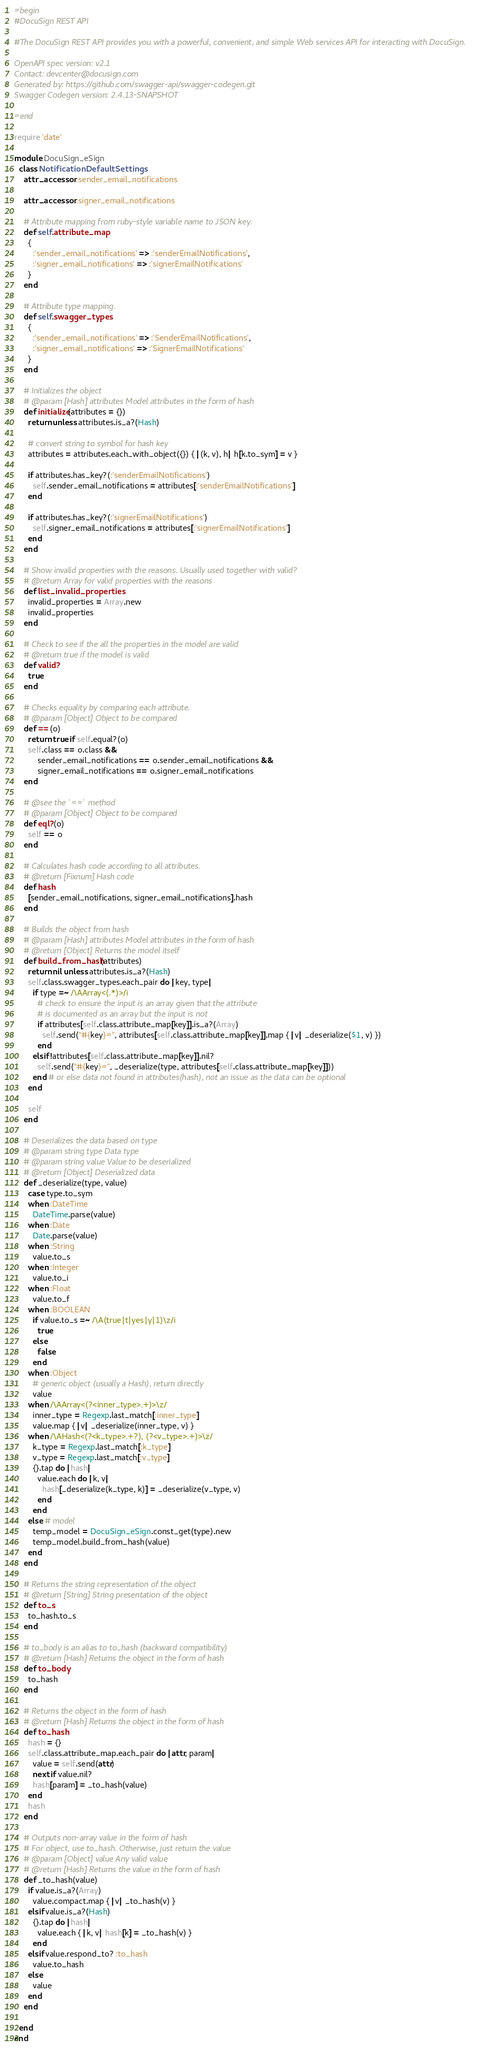<code> <loc_0><loc_0><loc_500><loc_500><_Ruby_>=begin
#DocuSign REST API

#The DocuSign REST API provides you with a powerful, convenient, and simple Web services API for interacting with DocuSign.

OpenAPI spec version: v2.1
Contact: devcenter@docusign.com
Generated by: https://github.com/swagger-api/swagger-codegen.git
Swagger Codegen version: 2.4.13-SNAPSHOT

=end

require 'date'

module DocuSign_eSign
  class NotificationDefaultSettings
    attr_accessor :sender_email_notifications

    attr_accessor :signer_email_notifications

    # Attribute mapping from ruby-style variable name to JSON key.
    def self.attribute_map
      {
        :'sender_email_notifications' => :'senderEmailNotifications',
        :'signer_email_notifications' => :'signerEmailNotifications'
      }
    end

    # Attribute type mapping.
    def self.swagger_types
      {
        :'sender_email_notifications' => :'SenderEmailNotifications',
        :'signer_email_notifications' => :'SignerEmailNotifications'
      }
    end

    # Initializes the object
    # @param [Hash] attributes Model attributes in the form of hash
    def initialize(attributes = {})
      return unless attributes.is_a?(Hash)

      # convert string to symbol for hash key
      attributes = attributes.each_with_object({}) { |(k, v), h| h[k.to_sym] = v }

      if attributes.has_key?(:'senderEmailNotifications')
        self.sender_email_notifications = attributes[:'senderEmailNotifications']
      end

      if attributes.has_key?(:'signerEmailNotifications')
        self.signer_email_notifications = attributes[:'signerEmailNotifications']
      end
    end

    # Show invalid properties with the reasons. Usually used together with valid?
    # @return Array for valid properties with the reasons
    def list_invalid_properties
      invalid_properties = Array.new
      invalid_properties
    end

    # Check to see if the all the properties in the model are valid
    # @return true if the model is valid
    def valid?
      true
    end

    # Checks equality by comparing each attribute.
    # @param [Object] Object to be compared
    def ==(o)
      return true if self.equal?(o)
      self.class == o.class &&
          sender_email_notifications == o.sender_email_notifications &&
          signer_email_notifications == o.signer_email_notifications
    end

    # @see the `==` method
    # @param [Object] Object to be compared
    def eql?(o)
      self == o
    end

    # Calculates hash code according to all attributes.
    # @return [Fixnum] Hash code
    def hash
      [sender_email_notifications, signer_email_notifications].hash
    end

    # Builds the object from hash
    # @param [Hash] attributes Model attributes in the form of hash
    # @return [Object] Returns the model itself
    def build_from_hash(attributes)
      return nil unless attributes.is_a?(Hash)
      self.class.swagger_types.each_pair do |key, type|
        if type =~ /\AArray<(.*)>/i
          # check to ensure the input is an array given that the attribute
          # is documented as an array but the input is not
          if attributes[self.class.attribute_map[key]].is_a?(Array)
            self.send("#{key}=", attributes[self.class.attribute_map[key]].map { |v| _deserialize($1, v) })
          end
        elsif !attributes[self.class.attribute_map[key]].nil?
          self.send("#{key}=", _deserialize(type, attributes[self.class.attribute_map[key]]))
        end # or else data not found in attributes(hash), not an issue as the data can be optional
      end

      self
    end

    # Deserializes the data based on type
    # @param string type Data type
    # @param string value Value to be deserialized
    # @return [Object] Deserialized data
    def _deserialize(type, value)
      case type.to_sym
      when :DateTime
        DateTime.parse(value)
      when :Date
        Date.parse(value)
      when :String
        value.to_s
      when :Integer
        value.to_i
      when :Float
        value.to_f
      when :BOOLEAN
        if value.to_s =~ /\A(true|t|yes|y|1)\z/i
          true
        else
          false
        end
      when :Object
        # generic object (usually a Hash), return directly
        value
      when /\AArray<(?<inner_type>.+)>\z/
        inner_type = Regexp.last_match[:inner_type]
        value.map { |v| _deserialize(inner_type, v) }
      when /\AHash<(?<k_type>.+?), (?<v_type>.+)>\z/
        k_type = Regexp.last_match[:k_type]
        v_type = Regexp.last_match[:v_type]
        {}.tap do |hash|
          value.each do |k, v|
            hash[_deserialize(k_type, k)] = _deserialize(v_type, v)
          end
        end
      else # model
        temp_model = DocuSign_eSign.const_get(type).new
        temp_model.build_from_hash(value)
      end
    end

    # Returns the string representation of the object
    # @return [String] String presentation of the object
    def to_s
      to_hash.to_s
    end

    # to_body is an alias to to_hash (backward compatibility)
    # @return [Hash] Returns the object in the form of hash
    def to_body
      to_hash
    end

    # Returns the object in the form of hash
    # @return [Hash] Returns the object in the form of hash
    def to_hash
      hash = {}
      self.class.attribute_map.each_pair do |attr, param|
        value = self.send(attr)
        next if value.nil?
        hash[param] = _to_hash(value)
      end
      hash
    end

    # Outputs non-array value in the form of hash
    # For object, use to_hash. Otherwise, just return the value
    # @param [Object] value Any valid value
    # @return [Hash] Returns the value in the form of hash
    def _to_hash(value)
      if value.is_a?(Array)
        value.compact.map { |v| _to_hash(v) }
      elsif value.is_a?(Hash)
        {}.tap do |hash|
          value.each { |k, v| hash[k] = _to_hash(v) }
        end
      elsif value.respond_to? :to_hash
        value.to_hash
      else
        value
      end
    end

  end
end
</code> 